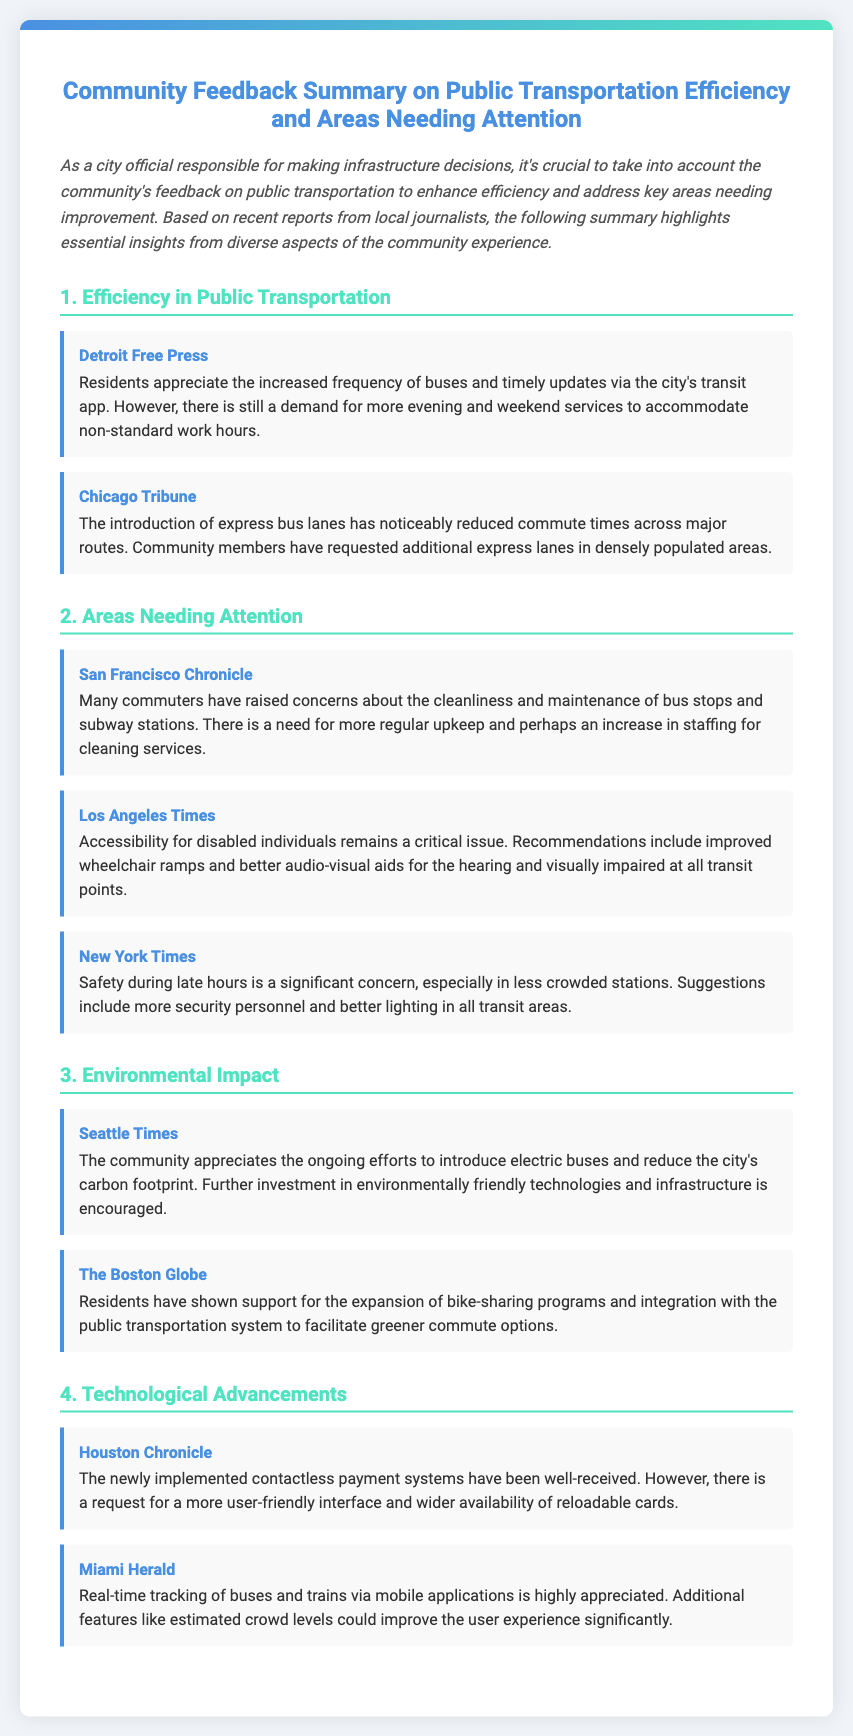What is the title of the document? The title of the document is stated at the top of the envelope.
Answer: Community Feedback Summary on Public Transportation Efficiency and Areas Needing Attention Who reported on the cleanliness concerns of bus stops? The source is mentioned in the feedback regarding cleanliness and maintenance issues of public transportation.
Answer: San Francisco Chronicle What has been appreciated by the community regarding buses? The feedback item mentions a specific aspect that the residents have expressed appreciation for in their public transportation.
Answer: Increased frequency of buses Which area is highlighted as needing more regular upkeep? The feedback item points to a specific area that requires attention and maintenance based on community input.
Answer: Bus stops and subway stations What safety issue is mentioned in the document? The document discusses a safety concern raised by commuters regarding late-night travel.
Answer: Safety during late hours How has the community responded to the electric buses? The feedback item outlines the community’s stance on environmental initiatives involving transportation.
Answer: Appreciated What kind of payment system is well-received? The feedback mentions a specific technological advance that has been positively received by the community.
Answer: Contactless payment systems Which city's feedback emphasized better audio-visual aids? This question pertains to identifying the city associated with a specific accessibility concern in the feedback.
Answer: Los Angeles What recommendation was made for express bus lanes? The feedback calls for an action regarding the establishment of additional infrastructure.
Answer: Additional express lanes in densely populated areas 